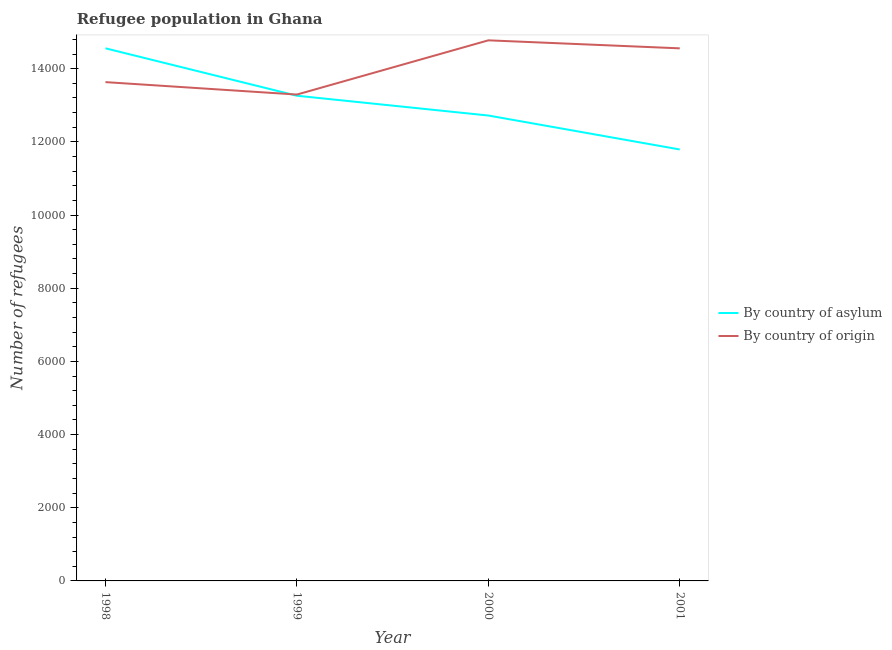How many different coloured lines are there?
Offer a very short reply. 2. Does the line corresponding to number of refugees by country of asylum intersect with the line corresponding to number of refugees by country of origin?
Give a very brief answer. Yes. Is the number of lines equal to the number of legend labels?
Offer a very short reply. Yes. What is the number of refugees by country of asylum in 2000?
Give a very brief answer. 1.27e+04. Across all years, what is the maximum number of refugees by country of asylum?
Give a very brief answer. 1.46e+04. Across all years, what is the minimum number of refugees by country of asylum?
Provide a short and direct response. 1.18e+04. In which year was the number of refugees by country of asylum maximum?
Provide a short and direct response. 1998. In which year was the number of refugees by country of asylum minimum?
Provide a short and direct response. 2001. What is the total number of refugees by country of origin in the graph?
Offer a very short reply. 5.63e+04. What is the difference between the number of refugees by country of asylum in 2000 and that in 2001?
Ensure brevity in your answer.  928. What is the difference between the number of refugees by country of origin in 1998 and the number of refugees by country of asylum in 1999?
Ensure brevity in your answer.  372. What is the average number of refugees by country of asylum per year?
Provide a succinct answer. 1.31e+04. In the year 2001, what is the difference between the number of refugees by country of origin and number of refugees by country of asylum?
Your answer should be very brief. 2764. What is the ratio of the number of refugees by country of origin in 1998 to that in 2000?
Offer a terse response. 0.92. What is the difference between the highest and the second highest number of refugees by country of asylum?
Ensure brevity in your answer.  1296. What is the difference between the highest and the lowest number of refugees by country of origin?
Make the answer very short. 1482. In how many years, is the number of refugees by country of asylum greater than the average number of refugees by country of asylum taken over all years?
Provide a short and direct response. 2. Is the number of refugees by country of asylum strictly greater than the number of refugees by country of origin over the years?
Offer a very short reply. No. Are the values on the major ticks of Y-axis written in scientific E-notation?
Offer a very short reply. No. Does the graph contain grids?
Provide a succinct answer. No. Where does the legend appear in the graph?
Provide a succinct answer. Center right. What is the title of the graph?
Give a very brief answer. Refugee population in Ghana. What is the label or title of the X-axis?
Offer a terse response. Year. What is the label or title of the Y-axis?
Offer a terse response. Number of refugees. What is the Number of refugees in By country of asylum in 1998?
Your answer should be very brief. 1.46e+04. What is the Number of refugees of By country of origin in 1998?
Your response must be concise. 1.36e+04. What is the Number of refugees of By country of asylum in 1999?
Provide a succinct answer. 1.33e+04. What is the Number of refugees of By country of origin in 1999?
Your answer should be very brief. 1.33e+04. What is the Number of refugees in By country of asylum in 2000?
Provide a succinct answer. 1.27e+04. What is the Number of refugees of By country of origin in 2000?
Ensure brevity in your answer.  1.48e+04. What is the Number of refugees in By country of asylum in 2001?
Offer a very short reply. 1.18e+04. What is the Number of refugees of By country of origin in 2001?
Your response must be concise. 1.46e+04. Across all years, what is the maximum Number of refugees in By country of asylum?
Your answer should be compact. 1.46e+04. Across all years, what is the maximum Number of refugees of By country of origin?
Provide a short and direct response. 1.48e+04. Across all years, what is the minimum Number of refugees of By country of asylum?
Keep it short and to the point. 1.18e+04. Across all years, what is the minimum Number of refugees in By country of origin?
Provide a succinct answer. 1.33e+04. What is the total Number of refugees in By country of asylum in the graph?
Give a very brief answer. 5.23e+04. What is the total Number of refugees of By country of origin in the graph?
Give a very brief answer. 5.63e+04. What is the difference between the Number of refugees of By country of asylum in 1998 and that in 1999?
Give a very brief answer. 1296. What is the difference between the Number of refugees of By country of origin in 1998 and that in 1999?
Your answer should be very brief. 340. What is the difference between the Number of refugees in By country of asylum in 1998 and that in 2000?
Your answer should be very brief. 1837. What is the difference between the Number of refugees of By country of origin in 1998 and that in 2000?
Your response must be concise. -1142. What is the difference between the Number of refugees in By country of asylum in 1998 and that in 2001?
Your answer should be very brief. 2765. What is the difference between the Number of refugees of By country of origin in 1998 and that in 2001?
Your answer should be very brief. -923. What is the difference between the Number of refugees of By country of asylum in 1999 and that in 2000?
Keep it short and to the point. 541. What is the difference between the Number of refugees of By country of origin in 1999 and that in 2000?
Offer a terse response. -1482. What is the difference between the Number of refugees in By country of asylum in 1999 and that in 2001?
Provide a short and direct response. 1469. What is the difference between the Number of refugees of By country of origin in 1999 and that in 2001?
Your response must be concise. -1263. What is the difference between the Number of refugees of By country of asylum in 2000 and that in 2001?
Keep it short and to the point. 928. What is the difference between the Number of refugees in By country of origin in 2000 and that in 2001?
Keep it short and to the point. 219. What is the difference between the Number of refugees in By country of asylum in 1998 and the Number of refugees in By country of origin in 1999?
Offer a very short reply. 1264. What is the difference between the Number of refugees of By country of asylum in 1998 and the Number of refugees of By country of origin in 2000?
Offer a terse response. -218. What is the difference between the Number of refugees of By country of asylum in 1999 and the Number of refugees of By country of origin in 2000?
Offer a terse response. -1514. What is the difference between the Number of refugees of By country of asylum in 1999 and the Number of refugees of By country of origin in 2001?
Provide a succinct answer. -1295. What is the difference between the Number of refugees in By country of asylum in 2000 and the Number of refugees in By country of origin in 2001?
Ensure brevity in your answer.  -1836. What is the average Number of refugees of By country of asylum per year?
Provide a succinct answer. 1.31e+04. What is the average Number of refugees of By country of origin per year?
Make the answer very short. 1.41e+04. In the year 1998, what is the difference between the Number of refugees in By country of asylum and Number of refugees in By country of origin?
Your answer should be compact. 924. In the year 1999, what is the difference between the Number of refugees in By country of asylum and Number of refugees in By country of origin?
Keep it short and to the point. -32. In the year 2000, what is the difference between the Number of refugees of By country of asylum and Number of refugees of By country of origin?
Provide a short and direct response. -2055. In the year 2001, what is the difference between the Number of refugees of By country of asylum and Number of refugees of By country of origin?
Ensure brevity in your answer.  -2764. What is the ratio of the Number of refugees in By country of asylum in 1998 to that in 1999?
Offer a terse response. 1.1. What is the ratio of the Number of refugees in By country of origin in 1998 to that in 1999?
Make the answer very short. 1.03. What is the ratio of the Number of refugees of By country of asylum in 1998 to that in 2000?
Keep it short and to the point. 1.14. What is the ratio of the Number of refugees in By country of origin in 1998 to that in 2000?
Ensure brevity in your answer.  0.92. What is the ratio of the Number of refugees of By country of asylum in 1998 to that in 2001?
Give a very brief answer. 1.23. What is the ratio of the Number of refugees of By country of origin in 1998 to that in 2001?
Keep it short and to the point. 0.94. What is the ratio of the Number of refugees of By country of asylum in 1999 to that in 2000?
Make the answer very short. 1.04. What is the ratio of the Number of refugees of By country of origin in 1999 to that in 2000?
Provide a short and direct response. 0.9. What is the ratio of the Number of refugees of By country of asylum in 1999 to that in 2001?
Make the answer very short. 1.12. What is the ratio of the Number of refugees of By country of origin in 1999 to that in 2001?
Your response must be concise. 0.91. What is the ratio of the Number of refugees of By country of asylum in 2000 to that in 2001?
Provide a succinct answer. 1.08. What is the difference between the highest and the second highest Number of refugees of By country of asylum?
Offer a terse response. 1296. What is the difference between the highest and the second highest Number of refugees of By country of origin?
Keep it short and to the point. 219. What is the difference between the highest and the lowest Number of refugees of By country of asylum?
Provide a succinct answer. 2765. What is the difference between the highest and the lowest Number of refugees of By country of origin?
Your answer should be compact. 1482. 